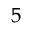<formula> <loc_0><loc_0><loc_500><loc_500>5</formula> 